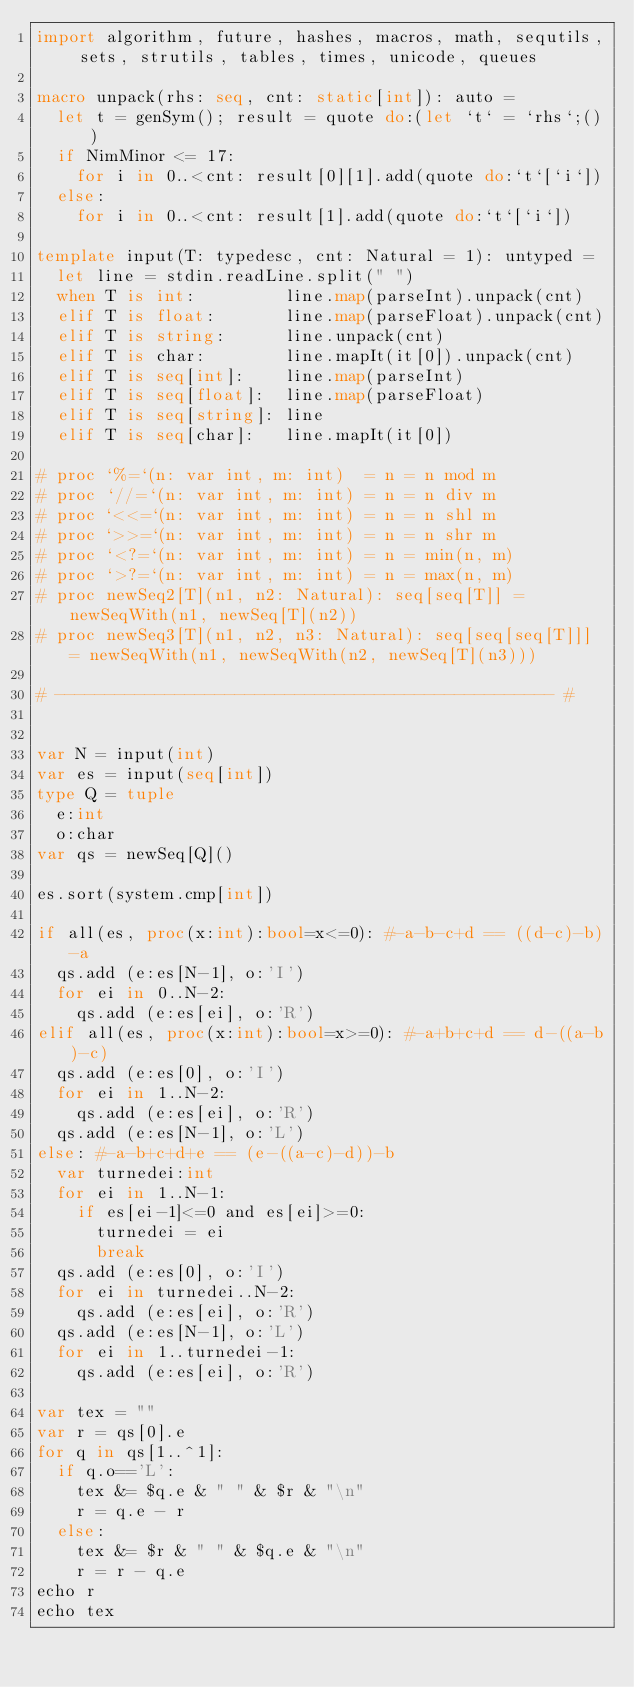<code> <loc_0><loc_0><loc_500><loc_500><_Nim_>import algorithm, future, hashes, macros, math, sequtils, sets, strutils, tables, times, unicode, queues
 
macro unpack(rhs: seq, cnt: static[int]): auto =
  let t = genSym(); result = quote do:(let `t` = `rhs`;())
  if NimMinor <= 17:
    for i in 0..<cnt: result[0][1].add(quote do:`t`[`i`])
  else:
    for i in 0..<cnt: result[1].add(quote do:`t`[`i`])
 
template input(T: typedesc, cnt: Natural = 1): untyped =
  let line = stdin.readLine.split(" ")
  when T is int:         line.map(parseInt).unpack(cnt)
  elif T is float:       line.map(parseFloat).unpack(cnt)
  elif T is string:      line.unpack(cnt)
  elif T is char:        line.mapIt(it[0]).unpack(cnt)
  elif T is seq[int]:    line.map(parseInt)
  elif T is seq[float]:  line.map(parseFloat)
  elif T is seq[string]: line
  elif T is seq[char]:   line.mapIt(it[0])
 
# proc `%=`(n: var int, m: int)  = n = n mod m
# proc `//=`(n: var int, m: int) = n = n div m
# proc `<<=`(n: var int, m: int) = n = n shl m
# proc `>>=`(n: var int, m: int) = n = n shr m
# proc `<?=`(n: var int, m: int) = n = min(n, m)
# proc `>?=`(n: var int, m: int) = n = max(n, m)
# proc newSeq2[T](n1, n2: Natural): seq[seq[T]] = newSeqWith(n1, newSeq[T](n2))
# proc newSeq3[T](n1, n2, n3: Natural): seq[seq[seq[T]]] = newSeqWith(n1, newSeqWith(n2, newSeq[T](n3)))
 
# -------------------------------------------------- #


var N = input(int)
var es = input(seq[int])
type Q = tuple
  e:int
  o:char
var qs = newSeq[Q]()

es.sort(system.cmp[int])

if all(es, proc(x:int):bool=x<=0): #-a-b-c+d == ((d-c)-b)-a
  qs.add (e:es[N-1], o:'I')
  for ei in 0..N-2:
    qs.add (e:es[ei], o:'R')
elif all(es, proc(x:int):bool=x>=0): #-a+b+c+d == d-((a-b)-c)
  qs.add (e:es[0], o:'I')
  for ei in 1..N-2:
    qs.add (e:es[ei], o:'R')
  qs.add (e:es[N-1], o:'L')
else: #-a-b+c+d+e == (e-((a-c)-d))-b
  var turnedei:int
  for ei in 1..N-1:
    if es[ei-1]<=0 and es[ei]>=0:
      turnedei = ei
      break
  qs.add (e:es[0], o:'I')
  for ei in turnedei..N-2:
    qs.add (e:es[ei], o:'R')
  qs.add (e:es[N-1], o:'L')
  for ei in 1..turnedei-1:
    qs.add (e:es[ei], o:'R')

var tex = ""
var r = qs[0].e
for q in qs[1..^1]:
  if q.o=='L':
    tex &= $q.e & " " & $r & "\n"
    r = q.e - r
  else:
    tex &= $r & " " & $q.e & "\n"
    r = r - q.e
echo r
echo tex</code> 